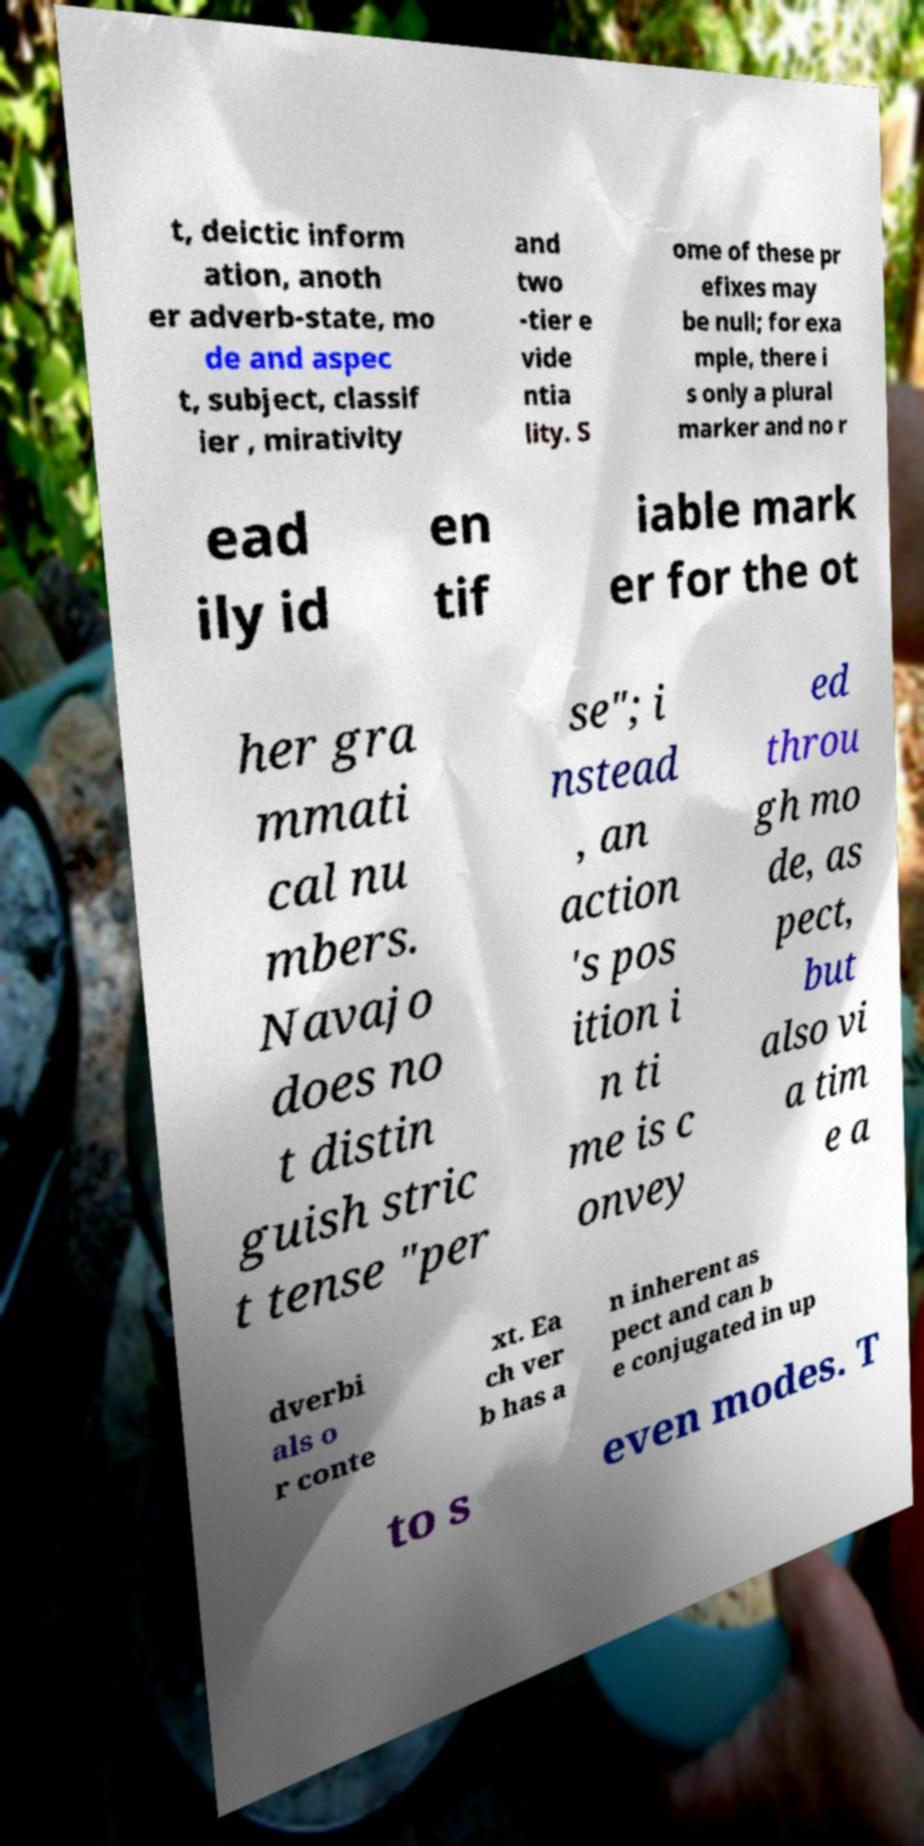Please identify and transcribe the text found in this image. t, deictic inform ation, anoth er adverb-state, mo de and aspec t, subject, classif ier , mirativity and two -tier e vide ntia lity. S ome of these pr efixes may be null; for exa mple, there i s only a plural marker and no r ead ily id en tif iable mark er for the ot her gra mmati cal nu mbers. Navajo does no t distin guish stric t tense "per se"; i nstead , an action 's pos ition i n ti me is c onvey ed throu gh mo de, as pect, but also vi a tim e a dverbi als o r conte xt. Ea ch ver b has a n inherent as pect and can b e conjugated in up to s even modes. T 